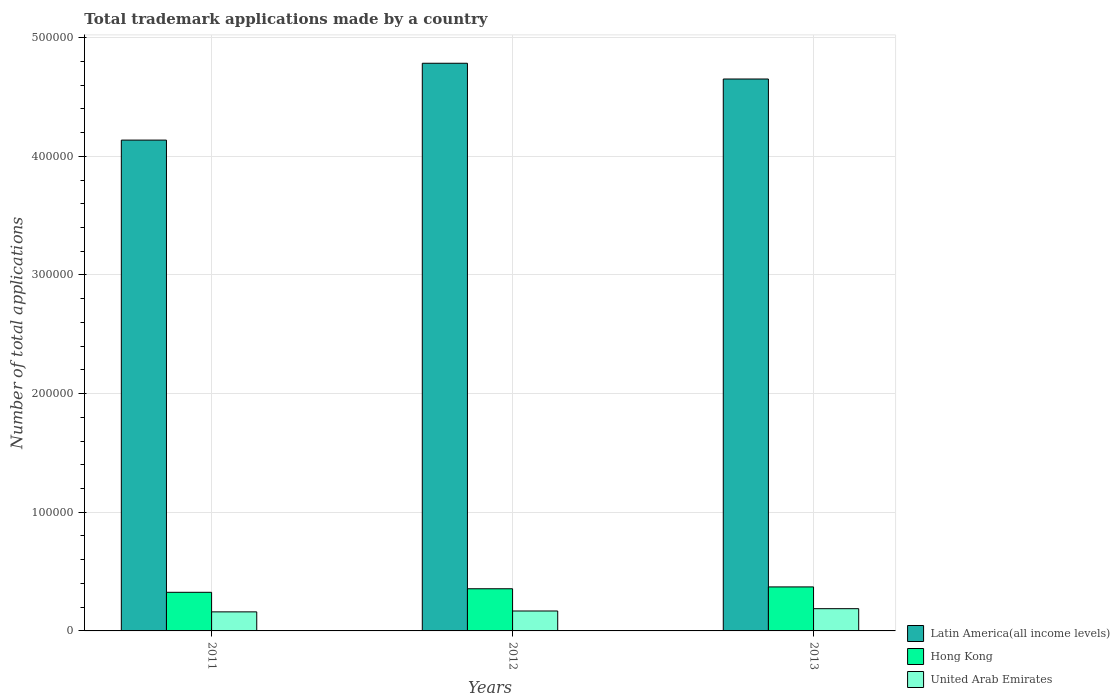How many groups of bars are there?
Make the answer very short. 3. How many bars are there on the 3rd tick from the left?
Your answer should be compact. 3. How many bars are there on the 1st tick from the right?
Offer a very short reply. 3. In how many cases, is the number of bars for a given year not equal to the number of legend labels?
Offer a very short reply. 0. What is the number of applications made by in United Arab Emirates in 2013?
Your answer should be compact. 1.87e+04. Across all years, what is the maximum number of applications made by in Latin America(all income levels)?
Your answer should be very brief. 4.78e+05. Across all years, what is the minimum number of applications made by in Latin America(all income levels)?
Offer a very short reply. 4.14e+05. In which year was the number of applications made by in Latin America(all income levels) minimum?
Your answer should be compact. 2011. What is the total number of applications made by in Latin America(all income levels) in the graph?
Keep it short and to the point. 1.36e+06. What is the difference between the number of applications made by in United Arab Emirates in 2012 and that in 2013?
Your answer should be compact. -1949. What is the difference between the number of applications made by in Latin America(all income levels) in 2011 and the number of applications made by in United Arab Emirates in 2013?
Provide a succinct answer. 3.95e+05. What is the average number of applications made by in United Arab Emirates per year?
Offer a very short reply. 1.72e+04. In the year 2013, what is the difference between the number of applications made by in Hong Kong and number of applications made by in Latin America(all income levels)?
Keep it short and to the point. -4.28e+05. What is the ratio of the number of applications made by in Latin America(all income levels) in 2011 to that in 2013?
Keep it short and to the point. 0.89. What is the difference between the highest and the second highest number of applications made by in United Arab Emirates?
Your answer should be compact. 1949. What is the difference between the highest and the lowest number of applications made by in United Arab Emirates?
Offer a terse response. 2688. In how many years, is the number of applications made by in Latin America(all income levels) greater than the average number of applications made by in Latin America(all income levels) taken over all years?
Make the answer very short. 2. Is the sum of the number of applications made by in United Arab Emirates in 2011 and 2012 greater than the maximum number of applications made by in Hong Kong across all years?
Provide a short and direct response. No. What does the 1st bar from the left in 2013 represents?
Provide a short and direct response. Latin America(all income levels). What does the 3rd bar from the right in 2013 represents?
Your answer should be compact. Latin America(all income levels). How many years are there in the graph?
Your answer should be compact. 3. Does the graph contain any zero values?
Provide a short and direct response. No. Where does the legend appear in the graph?
Provide a succinct answer. Bottom right. What is the title of the graph?
Make the answer very short. Total trademark applications made by a country. What is the label or title of the X-axis?
Offer a very short reply. Years. What is the label or title of the Y-axis?
Keep it short and to the point. Number of total applications. What is the Number of total applications in Latin America(all income levels) in 2011?
Offer a very short reply. 4.14e+05. What is the Number of total applications in Hong Kong in 2011?
Give a very brief answer. 3.25e+04. What is the Number of total applications of United Arab Emirates in 2011?
Your answer should be very brief. 1.61e+04. What is the Number of total applications in Latin America(all income levels) in 2012?
Your answer should be compact. 4.78e+05. What is the Number of total applications of Hong Kong in 2012?
Provide a short and direct response. 3.55e+04. What is the Number of total applications in United Arab Emirates in 2012?
Offer a terse response. 1.68e+04. What is the Number of total applications in Latin America(all income levels) in 2013?
Offer a very short reply. 4.65e+05. What is the Number of total applications of Hong Kong in 2013?
Offer a terse response. 3.71e+04. What is the Number of total applications in United Arab Emirates in 2013?
Give a very brief answer. 1.87e+04. Across all years, what is the maximum Number of total applications of Latin America(all income levels)?
Give a very brief answer. 4.78e+05. Across all years, what is the maximum Number of total applications in Hong Kong?
Your answer should be compact. 3.71e+04. Across all years, what is the maximum Number of total applications of United Arab Emirates?
Keep it short and to the point. 1.87e+04. Across all years, what is the minimum Number of total applications of Latin America(all income levels)?
Offer a terse response. 4.14e+05. Across all years, what is the minimum Number of total applications of Hong Kong?
Offer a terse response. 3.25e+04. Across all years, what is the minimum Number of total applications in United Arab Emirates?
Your answer should be very brief. 1.61e+04. What is the total Number of total applications of Latin America(all income levels) in the graph?
Provide a short and direct response. 1.36e+06. What is the total Number of total applications in Hong Kong in the graph?
Offer a terse response. 1.05e+05. What is the total Number of total applications of United Arab Emirates in the graph?
Ensure brevity in your answer.  5.16e+04. What is the difference between the Number of total applications of Latin America(all income levels) in 2011 and that in 2012?
Provide a succinct answer. -6.48e+04. What is the difference between the Number of total applications in Hong Kong in 2011 and that in 2012?
Your response must be concise. -2988. What is the difference between the Number of total applications of United Arab Emirates in 2011 and that in 2012?
Your answer should be compact. -739. What is the difference between the Number of total applications of Latin America(all income levels) in 2011 and that in 2013?
Make the answer very short. -5.15e+04. What is the difference between the Number of total applications in Hong Kong in 2011 and that in 2013?
Offer a terse response. -4550. What is the difference between the Number of total applications in United Arab Emirates in 2011 and that in 2013?
Keep it short and to the point. -2688. What is the difference between the Number of total applications of Latin America(all income levels) in 2012 and that in 2013?
Make the answer very short. 1.33e+04. What is the difference between the Number of total applications in Hong Kong in 2012 and that in 2013?
Keep it short and to the point. -1562. What is the difference between the Number of total applications in United Arab Emirates in 2012 and that in 2013?
Your response must be concise. -1949. What is the difference between the Number of total applications of Latin America(all income levels) in 2011 and the Number of total applications of Hong Kong in 2012?
Give a very brief answer. 3.78e+05. What is the difference between the Number of total applications in Latin America(all income levels) in 2011 and the Number of total applications in United Arab Emirates in 2012?
Provide a short and direct response. 3.97e+05. What is the difference between the Number of total applications in Hong Kong in 2011 and the Number of total applications in United Arab Emirates in 2012?
Your response must be concise. 1.57e+04. What is the difference between the Number of total applications of Latin America(all income levels) in 2011 and the Number of total applications of Hong Kong in 2013?
Ensure brevity in your answer.  3.77e+05. What is the difference between the Number of total applications of Latin America(all income levels) in 2011 and the Number of total applications of United Arab Emirates in 2013?
Provide a succinct answer. 3.95e+05. What is the difference between the Number of total applications of Hong Kong in 2011 and the Number of total applications of United Arab Emirates in 2013?
Provide a succinct answer. 1.38e+04. What is the difference between the Number of total applications of Latin America(all income levels) in 2012 and the Number of total applications of Hong Kong in 2013?
Provide a succinct answer. 4.41e+05. What is the difference between the Number of total applications in Latin America(all income levels) in 2012 and the Number of total applications in United Arab Emirates in 2013?
Ensure brevity in your answer.  4.60e+05. What is the difference between the Number of total applications in Hong Kong in 2012 and the Number of total applications in United Arab Emirates in 2013?
Your answer should be compact. 1.68e+04. What is the average Number of total applications in Latin America(all income levels) per year?
Your answer should be very brief. 4.52e+05. What is the average Number of total applications of Hong Kong per year?
Your answer should be compact. 3.51e+04. What is the average Number of total applications in United Arab Emirates per year?
Your answer should be very brief. 1.72e+04. In the year 2011, what is the difference between the Number of total applications in Latin America(all income levels) and Number of total applications in Hong Kong?
Give a very brief answer. 3.81e+05. In the year 2011, what is the difference between the Number of total applications of Latin America(all income levels) and Number of total applications of United Arab Emirates?
Your answer should be compact. 3.98e+05. In the year 2011, what is the difference between the Number of total applications of Hong Kong and Number of total applications of United Arab Emirates?
Offer a very short reply. 1.65e+04. In the year 2012, what is the difference between the Number of total applications in Latin America(all income levels) and Number of total applications in Hong Kong?
Provide a short and direct response. 4.43e+05. In the year 2012, what is the difference between the Number of total applications of Latin America(all income levels) and Number of total applications of United Arab Emirates?
Keep it short and to the point. 4.62e+05. In the year 2012, what is the difference between the Number of total applications in Hong Kong and Number of total applications in United Arab Emirates?
Your answer should be compact. 1.87e+04. In the year 2013, what is the difference between the Number of total applications in Latin America(all income levels) and Number of total applications in Hong Kong?
Ensure brevity in your answer.  4.28e+05. In the year 2013, what is the difference between the Number of total applications in Latin America(all income levels) and Number of total applications in United Arab Emirates?
Your answer should be very brief. 4.46e+05. In the year 2013, what is the difference between the Number of total applications of Hong Kong and Number of total applications of United Arab Emirates?
Provide a succinct answer. 1.83e+04. What is the ratio of the Number of total applications of Latin America(all income levels) in 2011 to that in 2012?
Ensure brevity in your answer.  0.86. What is the ratio of the Number of total applications of Hong Kong in 2011 to that in 2012?
Give a very brief answer. 0.92. What is the ratio of the Number of total applications in United Arab Emirates in 2011 to that in 2012?
Your answer should be compact. 0.96. What is the ratio of the Number of total applications in Latin America(all income levels) in 2011 to that in 2013?
Provide a succinct answer. 0.89. What is the ratio of the Number of total applications of Hong Kong in 2011 to that in 2013?
Provide a succinct answer. 0.88. What is the ratio of the Number of total applications of United Arab Emirates in 2011 to that in 2013?
Make the answer very short. 0.86. What is the ratio of the Number of total applications in Latin America(all income levels) in 2012 to that in 2013?
Offer a terse response. 1.03. What is the ratio of the Number of total applications of Hong Kong in 2012 to that in 2013?
Provide a short and direct response. 0.96. What is the ratio of the Number of total applications in United Arab Emirates in 2012 to that in 2013?
Your answer should be very brief. 0.9. What is the difference between the highest and the second highest Number of total applications in Latin America(all income levels)?
Give a very brief answer. 1.33e+04. What is the difference between the highest and the second highest Number of total applications in Hong Kong?
Make the answer very short. 1562. What is the difference between the highest and the second highest Number of total applications of United Arab Emirates?
Your answer should be compact. 1949. What is the difference between the highest and the lowest Number of total applications in Latin America(all income levels)?
Make the answer very short. 6.48e+04. What is the difference between the highest and the lowest Number of total applications of Hong Kong?
Your answer should be compact. 4550. What is the difference between the highest and the lowest Number of total applications of United Arab Emirates?
Ensure brevity in your answer.  2688. 